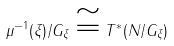<formula> <loc_0><loc_0><loc_500><loc_500>\mu ^ { - 1 } ( \xi ) / G _ { \xi } \cong T ^ { * } ( N / G _ { \xi } )</formula> 